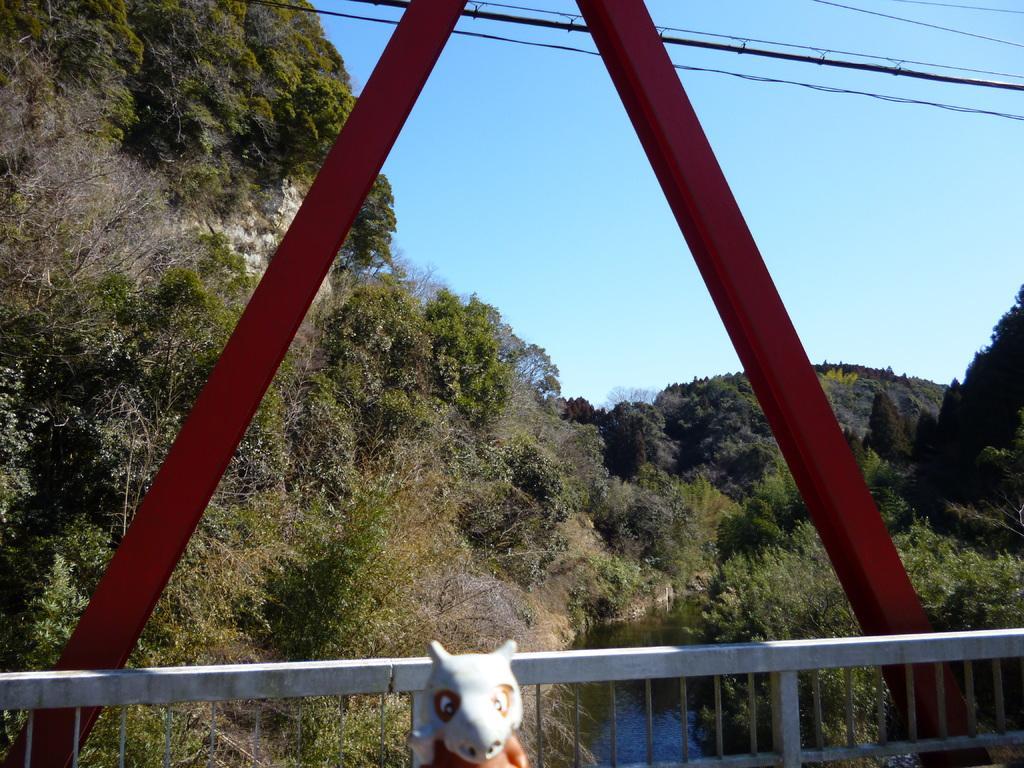How would you summarize this image in a sentence or two? In the picture we can see a part of the railing to the bridge and near it, we can see a small doll and behind it, we can see many trees and to the bottom we can see some water and in the background we can see the sky. 